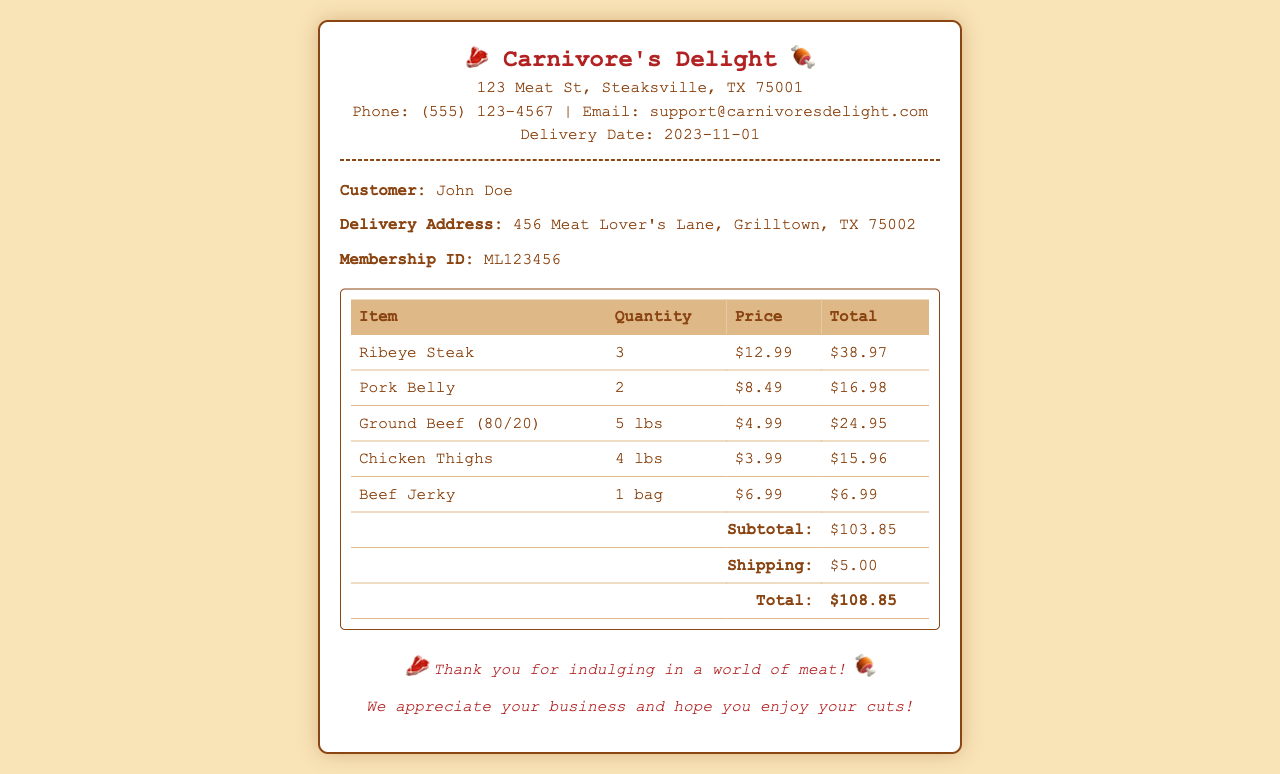What is the name of the customer? The document clearly states the customer's name in the customer details section.
Answer: John Doe What is the delivery date? The delivery date is prominently mentioned at the top of the receipt, indicating when the order will arrive.
Answer: 2023-11-01 How many Ribeye Steaks were ordered? The quantity of Ribeye Steaks is listed in the order summary table under the item description.
Answer: 3 What is the price of Ground Beef per pound? The pricing information for Ground Beef shows the price per pound in the order summary table.
Answer: $4.99 What is the total amount paid for the order? The total price is listed at the bottom of the order summary, clearly indicating the final amount due.
Answer: $108.85 What is the subtotal before shipping? The subtotal before shipping costs is provided in the order summary and is essential for the total calculation.
Answer: $103.85 How many pounds of Chicken Thighs were ordered? The order summary provides information on the weight of Chicken Thighs purchased.
Answer: 4 lbs What is the shipping cost for the order? The document states the shipping cost in the order summary section, contributing to the total amount.
Answer: $5.00 What was the quantity of Pork Belly ordered? The order summary includes the specific quantity of Pork Belly that was part of the purchase.
Answer: 2 